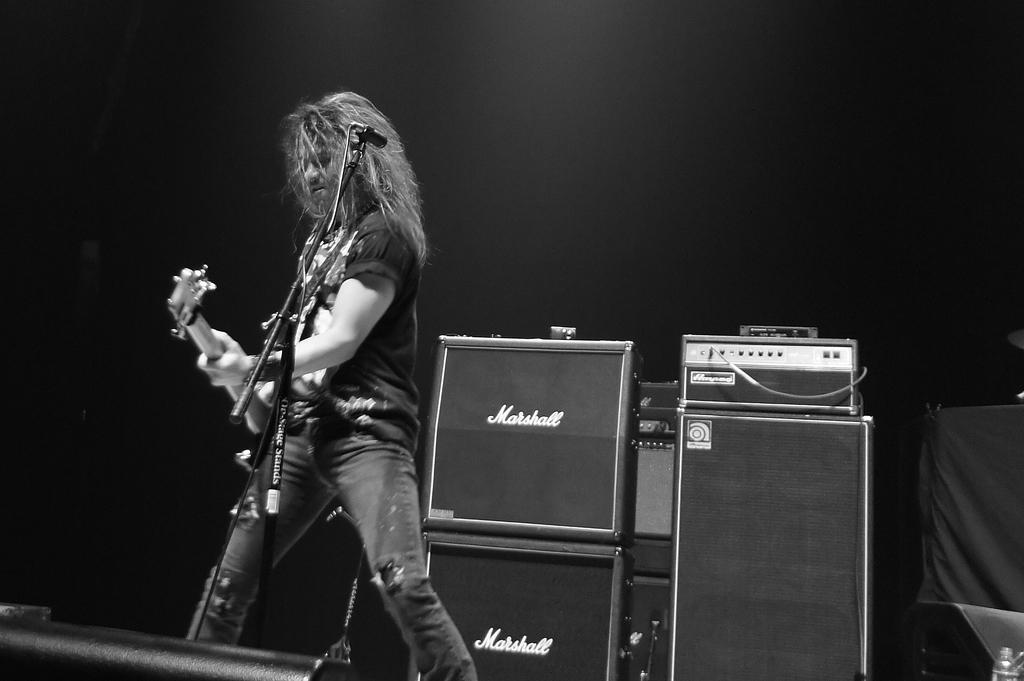Provide a one-sentence caption for the provided image. A guitaris plays his instrument in front of some Marshall amps. 